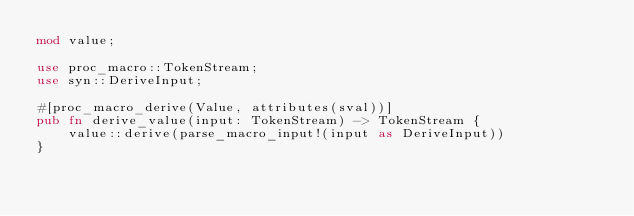<code> <loc_0><loc_0><loc_500><loc_500><_Rust_>mod value;

use proc_macro::TokenStream;
use syn::DeriveInput;

#[proc_macro_derive(Value, attributes(sval))]
pub fn derive_value(input: TokenStream) -> TokenStream {
    value::derive(parse_macro_input!(input as DeriveInput))
}
</code> 